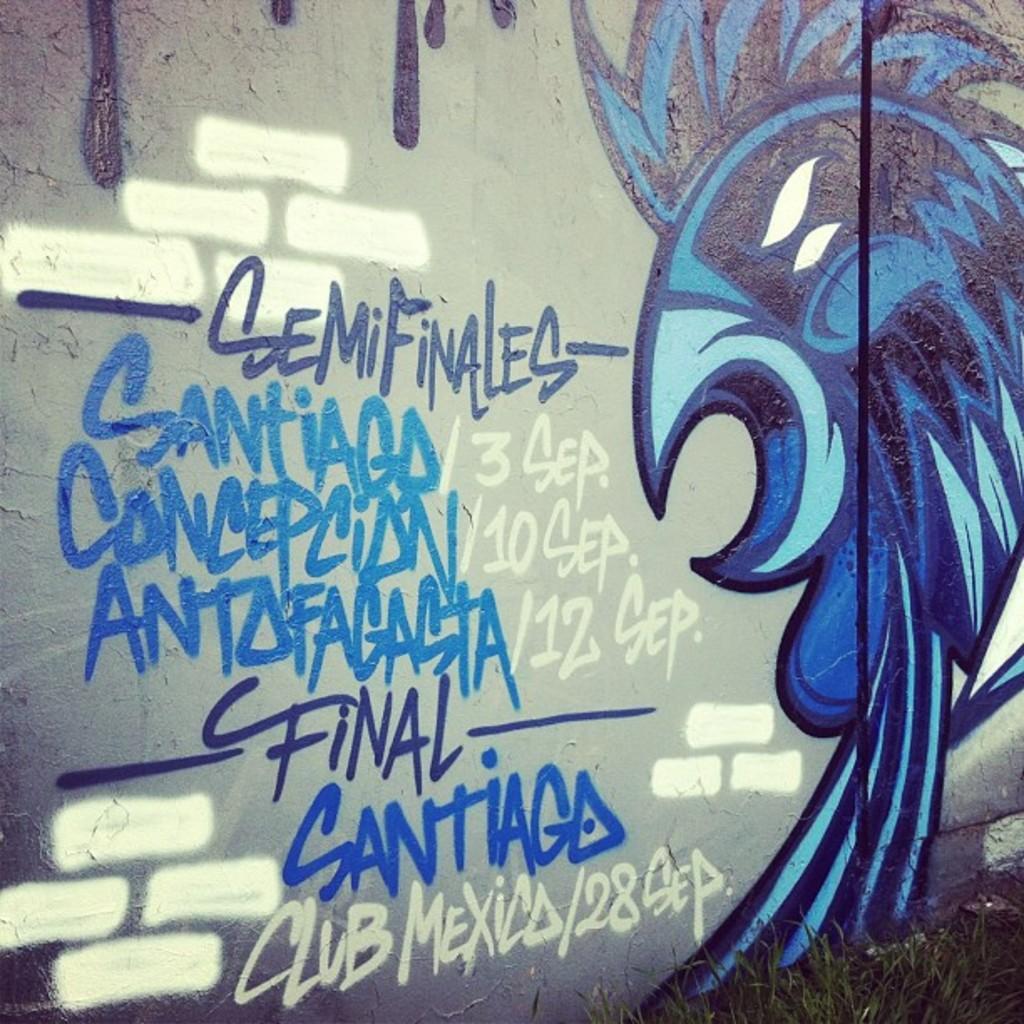Could you give a brief overview of what you see in this image? In this image I see the wall on which there is an art over here which is of light blue, dark blue and black in color and I see words and numbers written over here and I see the green grass over here. 